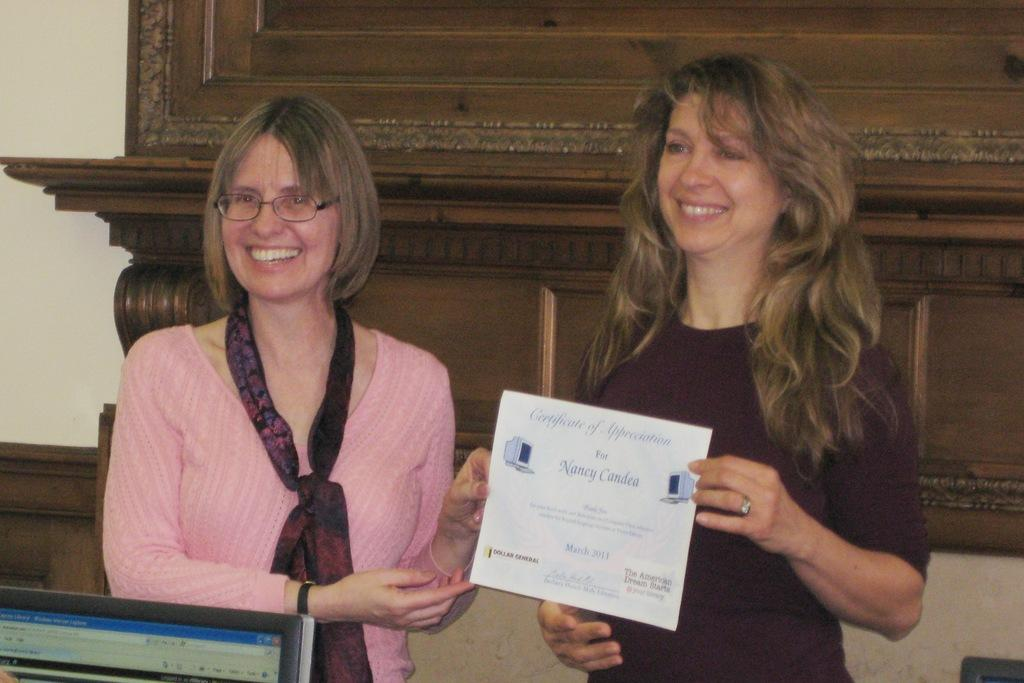<image>
Present a compact description of the photo's key features. A woman is holding a certificate of appreciation for Nancy. 